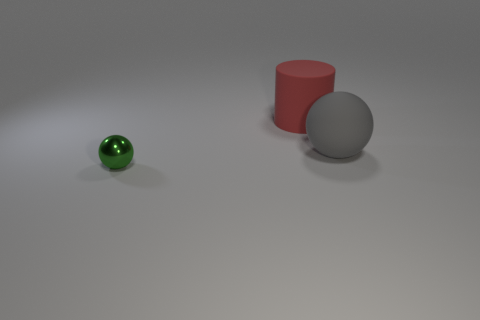Subtract all yellow balls. Subtract all gray cylinders. How many balls are left? 2 Add 1 large gray matte spheres. How many objects exist? 4 Subtract all balls. How many objects are left? 1 Add 2 brown metallic cylinders. How many brown metallic cylinders exist? 2 Subtract 0 green cubes. How many objects are left? 3 Subtract all tiny yellow spheres. Subtract all tiny green objects. How many objects are left? 2 Add 1 green spheres. How many green spheres are left? 2 